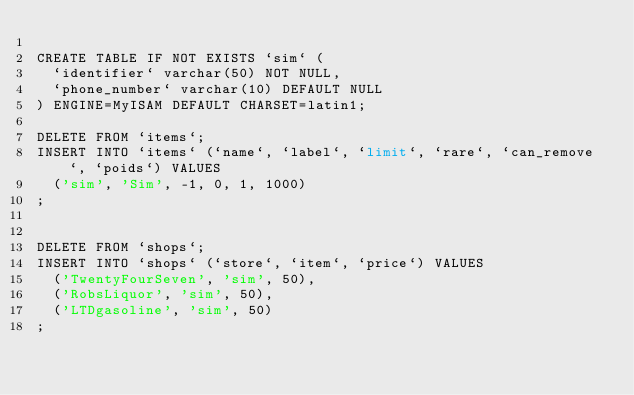<code> <loc_0><loc_0><loc_500><loc_500><_SQL_>
CREATE TABLE IF NOT EXISTS `sim` (
  `identifier` varchar(50) NOT NULL,
  `phone_number` varchar(10) DEFAULT NULL
) ENGINE=MyISAM DEFAULT CHARSET=latin1;

DELETE FROM `items`;
INSERT INTO `items` (`name`, `label`, `limit`, `rare`, `can_remove`, `poids`) VALUES
	('sim', 'Sim', -1, 0, 1, 1000)
;


DELETE FROM `shops`;
INSERT INTO `shops` (`store`, `item`, `price`) VALUES
	('TwentyFourSeven', 'sim', 50),
	('RobsLiquor', 'sim', 50),
	('LTDgasoline', 'sim', 50)
;
</code> 